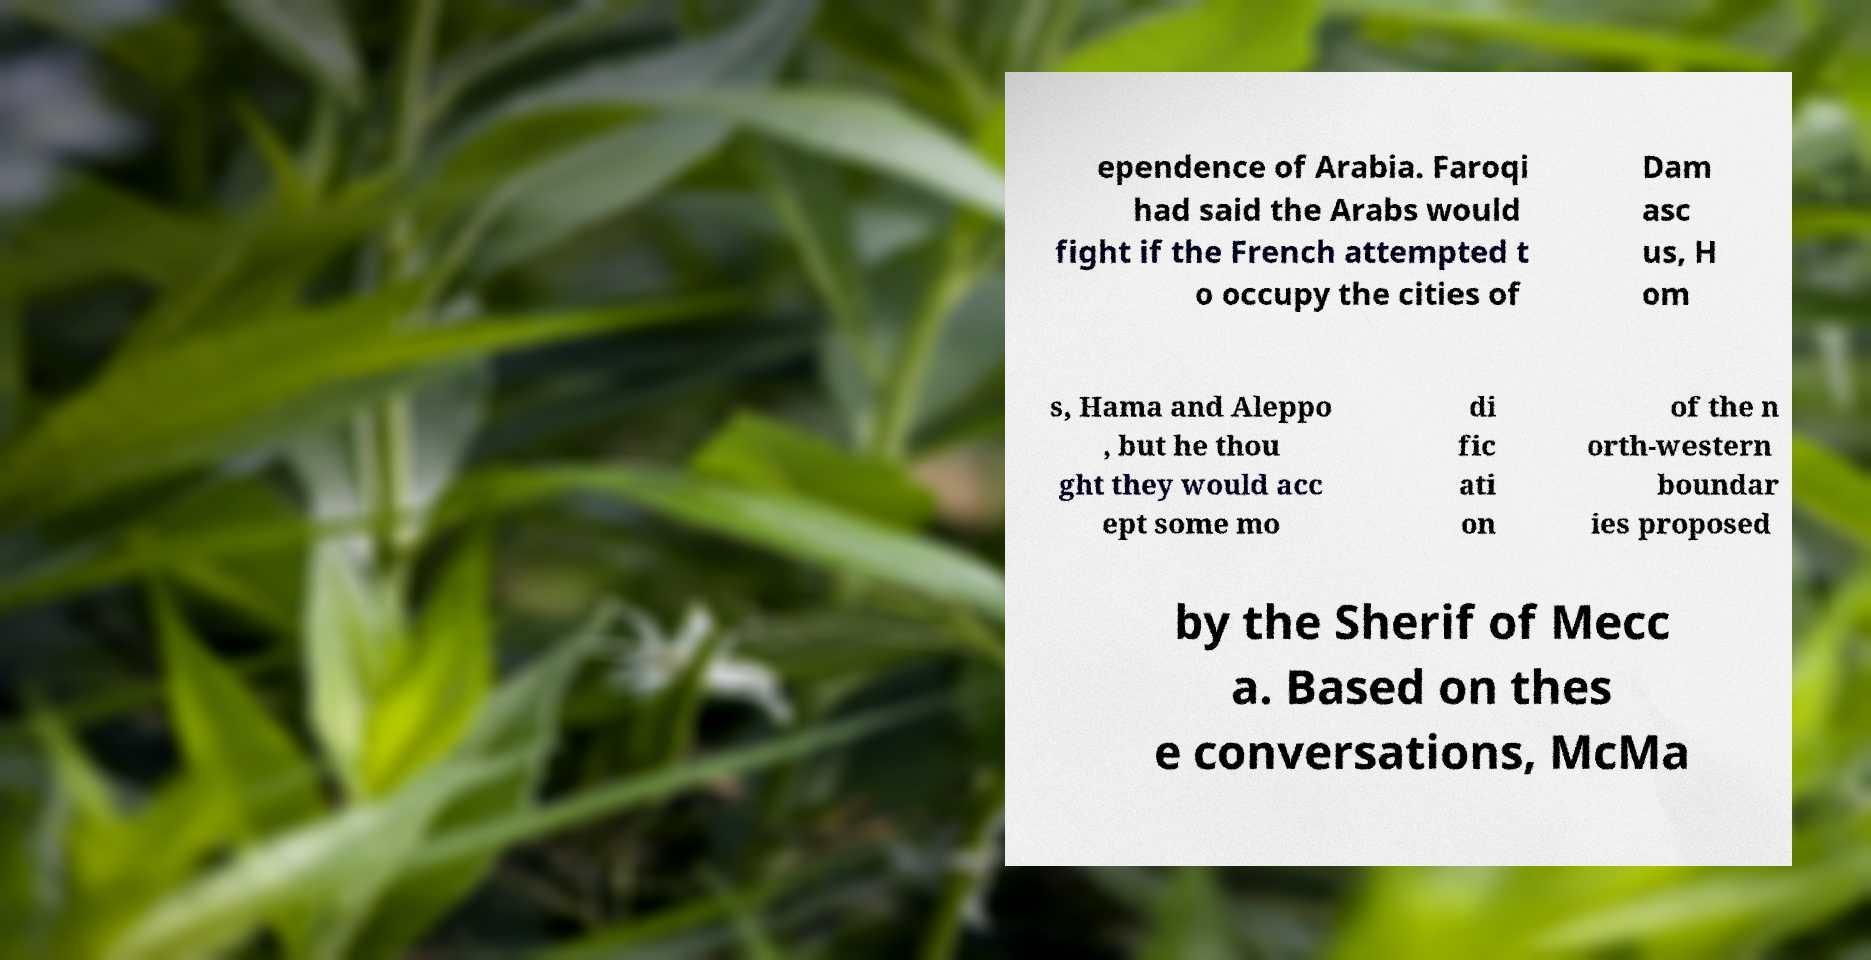Can you read and provide the text displayed in the image?This photo seems to have some interesting text. Can you extract and type it out for me? ependence of Arabia. Faroqi had said the Arabs would fight if the French attempted t o occupy the cities of Dam asc us, H om s, Hama and Aleppo , but he thou ght they would acc ept some mo di fic ati on of the n orth-western boundar ies proposed by the Sherif of Mecc a. Based on thes e conversations, McMa 